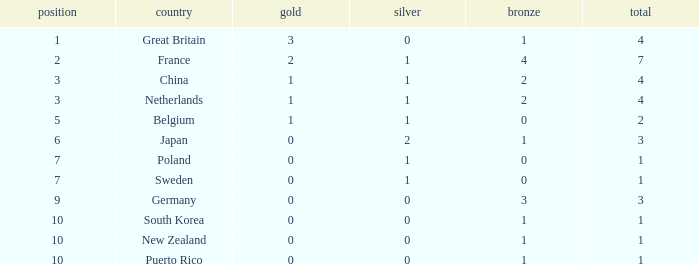Help me parse the entirety of this table. {'header': ['position', 'country', 'gold', 'silver', 'bronze', 'total'], 'rows': [['1', 'Great Britain', '3', '0', '1', '4'], ['2', 'France', '2', '1', '4', '7'], ['3', 'China', '1', '1', '2', '4'], ['3', 'Netherlands', '1', '1', '2', '4'], ['5', 'Belgium', '1', '1', '0', '2'], ['6', 'Japan', '0', '2', '1', '3'], ['7', 'Poland', '0', '1', '0', '1'], ['7', 'Sweden', '0', '1', '0', '1'], ['9', 'Germany', '0', '0', '3', '3'], ['10', 'South Korea', '0', '0', '1', '1'], ['10', 'New Zealand', '0', '0', '1', '1'], ['10', 'Puerto Rico', '0', '0', '1', '1']]} What is the smallest number of gold where the total is less than 3 and the silver count is 2? None. 